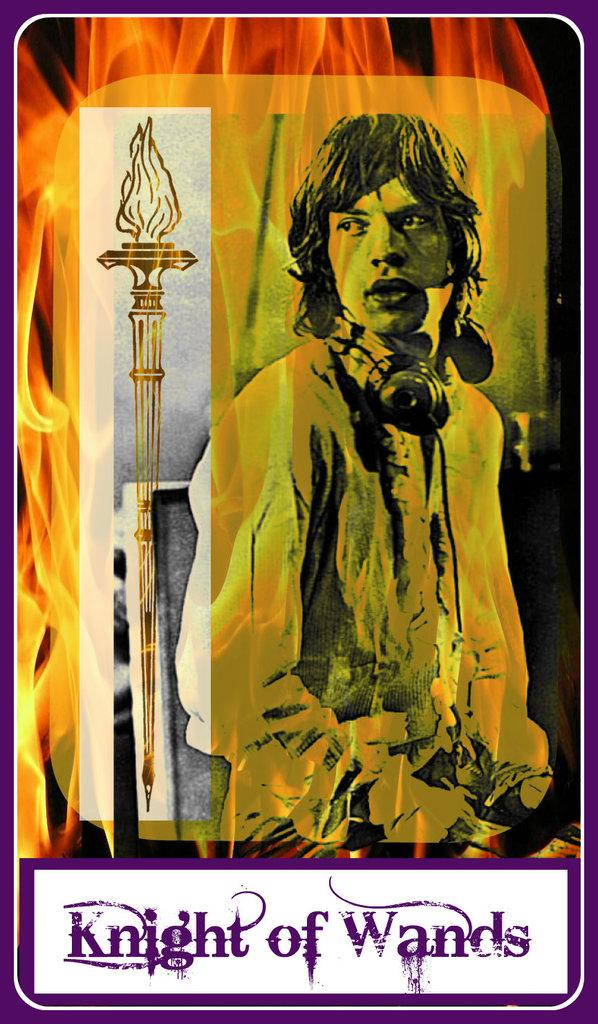<image>
Describe the image concisely. A colorful playing type card with a burning torch and the words Knight o Wands at the bottom . 